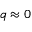Convert formula to latex. <formula><loc_0><loc_0><loc_500><loc_500>q \approx 0</formula> 